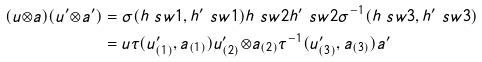<formula> <loc_0><loc_0><loc_500><loc_500>( u { \otimes } a ) ( u ^ { \prime } { \otimes } a ^ { \prime } ) & = \sigma ( h \ s w 1 , h ^ { \prime } \ s w 1 ) h \ s w 2 h ^ { \prime } \ s w 2 \sigma ^ { - 1 } ( h \ s w 3 , h ^ { \prime } \ s w 3 ) \\ & = u \tau ( u ^ { \prime } _ { ( 1 ) } , a _ { ( 1 ) } ) u ^ { \prime } _ { ( 2 ) } { \otimes } a _ { ( 2 ) } \tau ^ { - 1 } ( u ^ { \prime } _ { ( 3 ) } , a _ { ( 3 ) } ) a ^ { \prime }</formula> 